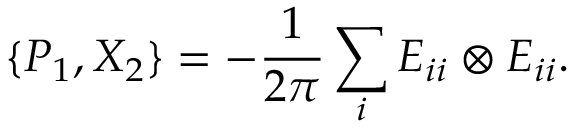<formula> <loc_0><loc_0><loc_500><loc_500>\{ P _ { 1 } , X _ { 2 } \} = - \frac { 1 } { 2 \pi } \sum _ { i } E _ { i i } \otimes E _ { i i } .</formula> 